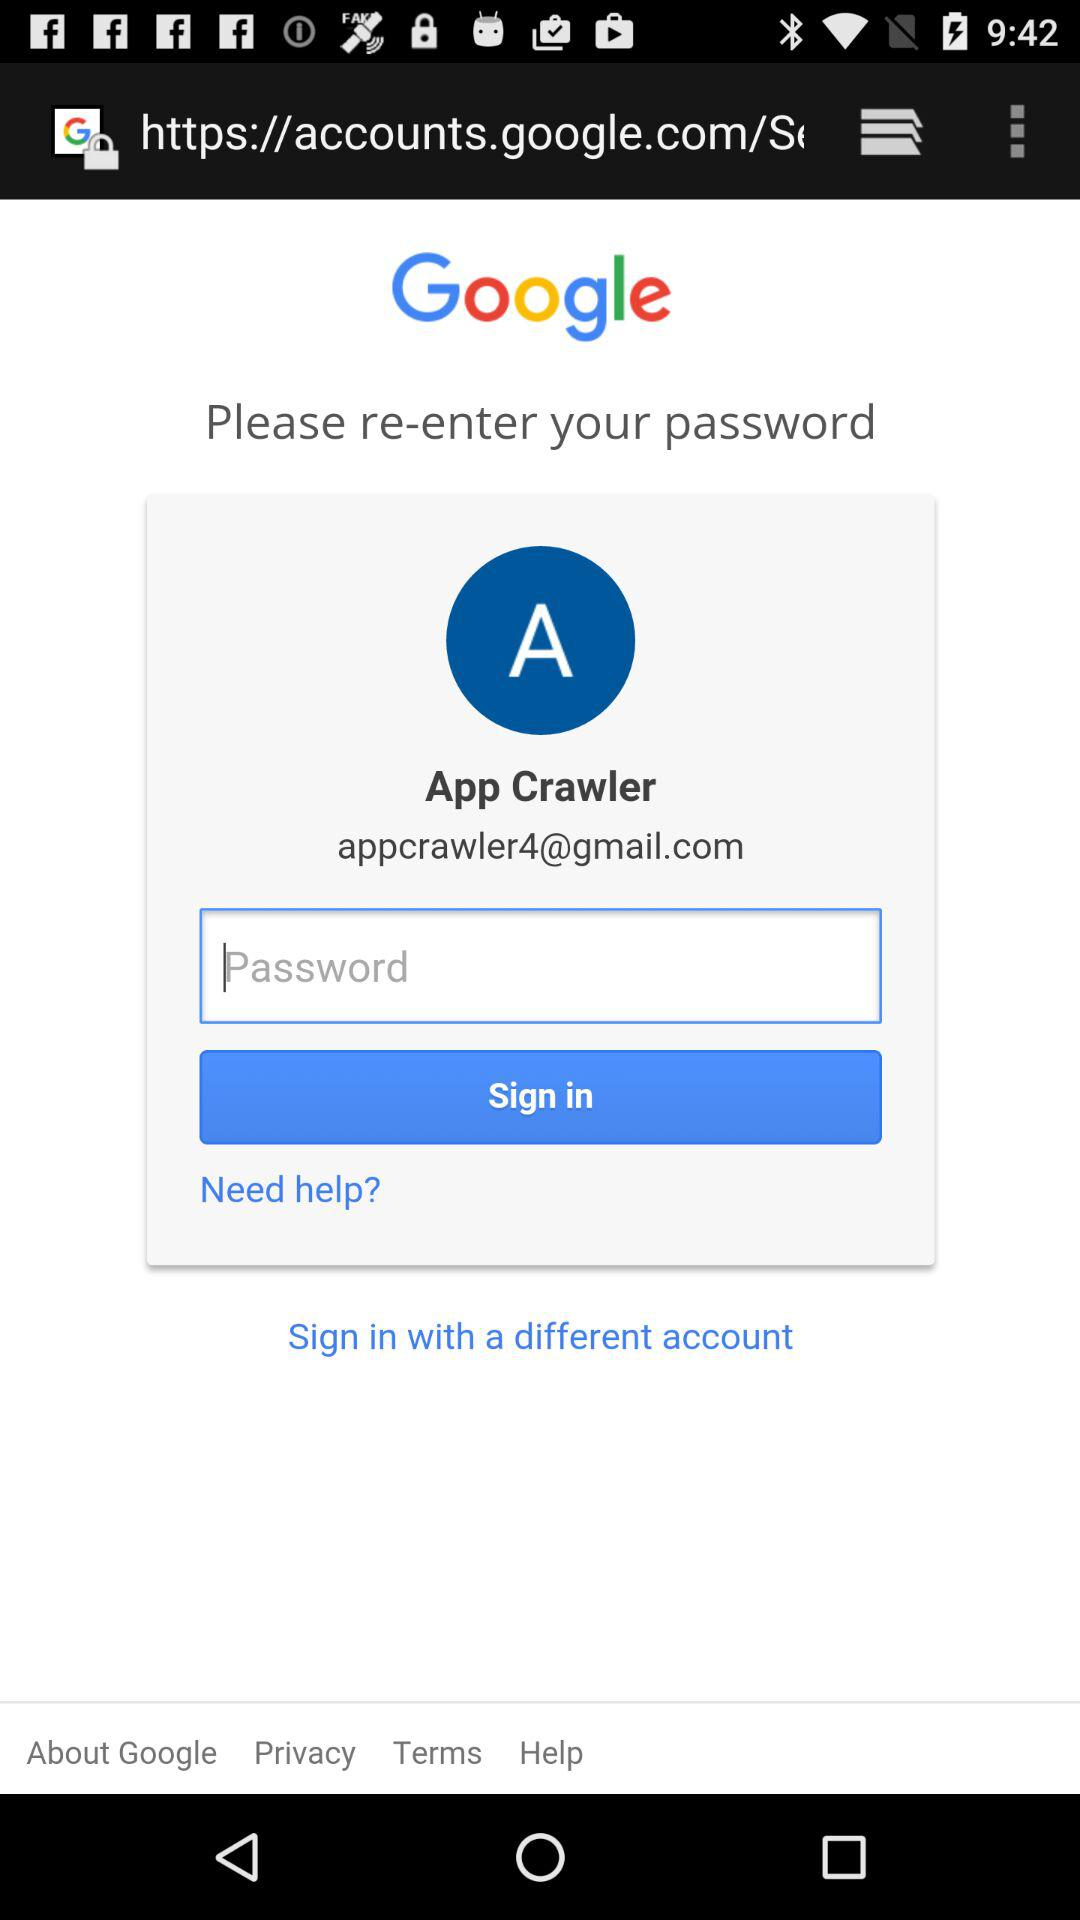What is the user name? The user name is App Crawler. 